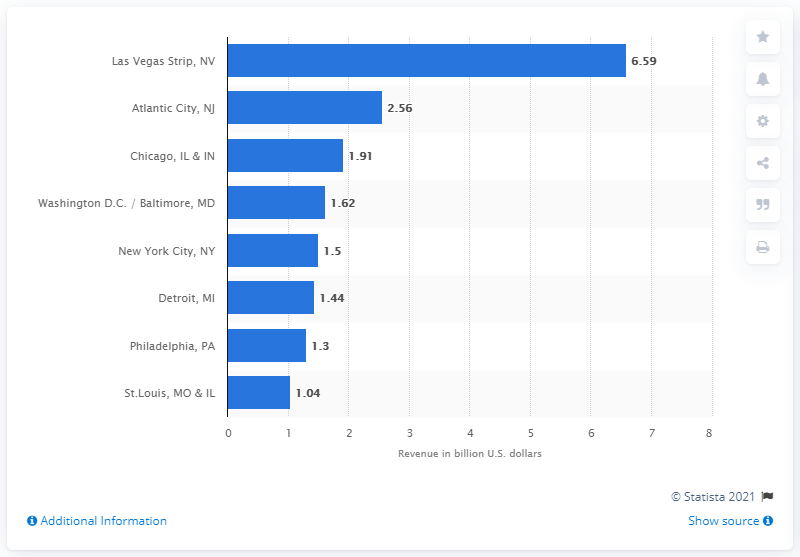Specify some key components in this picture. The Las Vegas Strip was worth approximately $6.59 billion in dollars in 2018. 